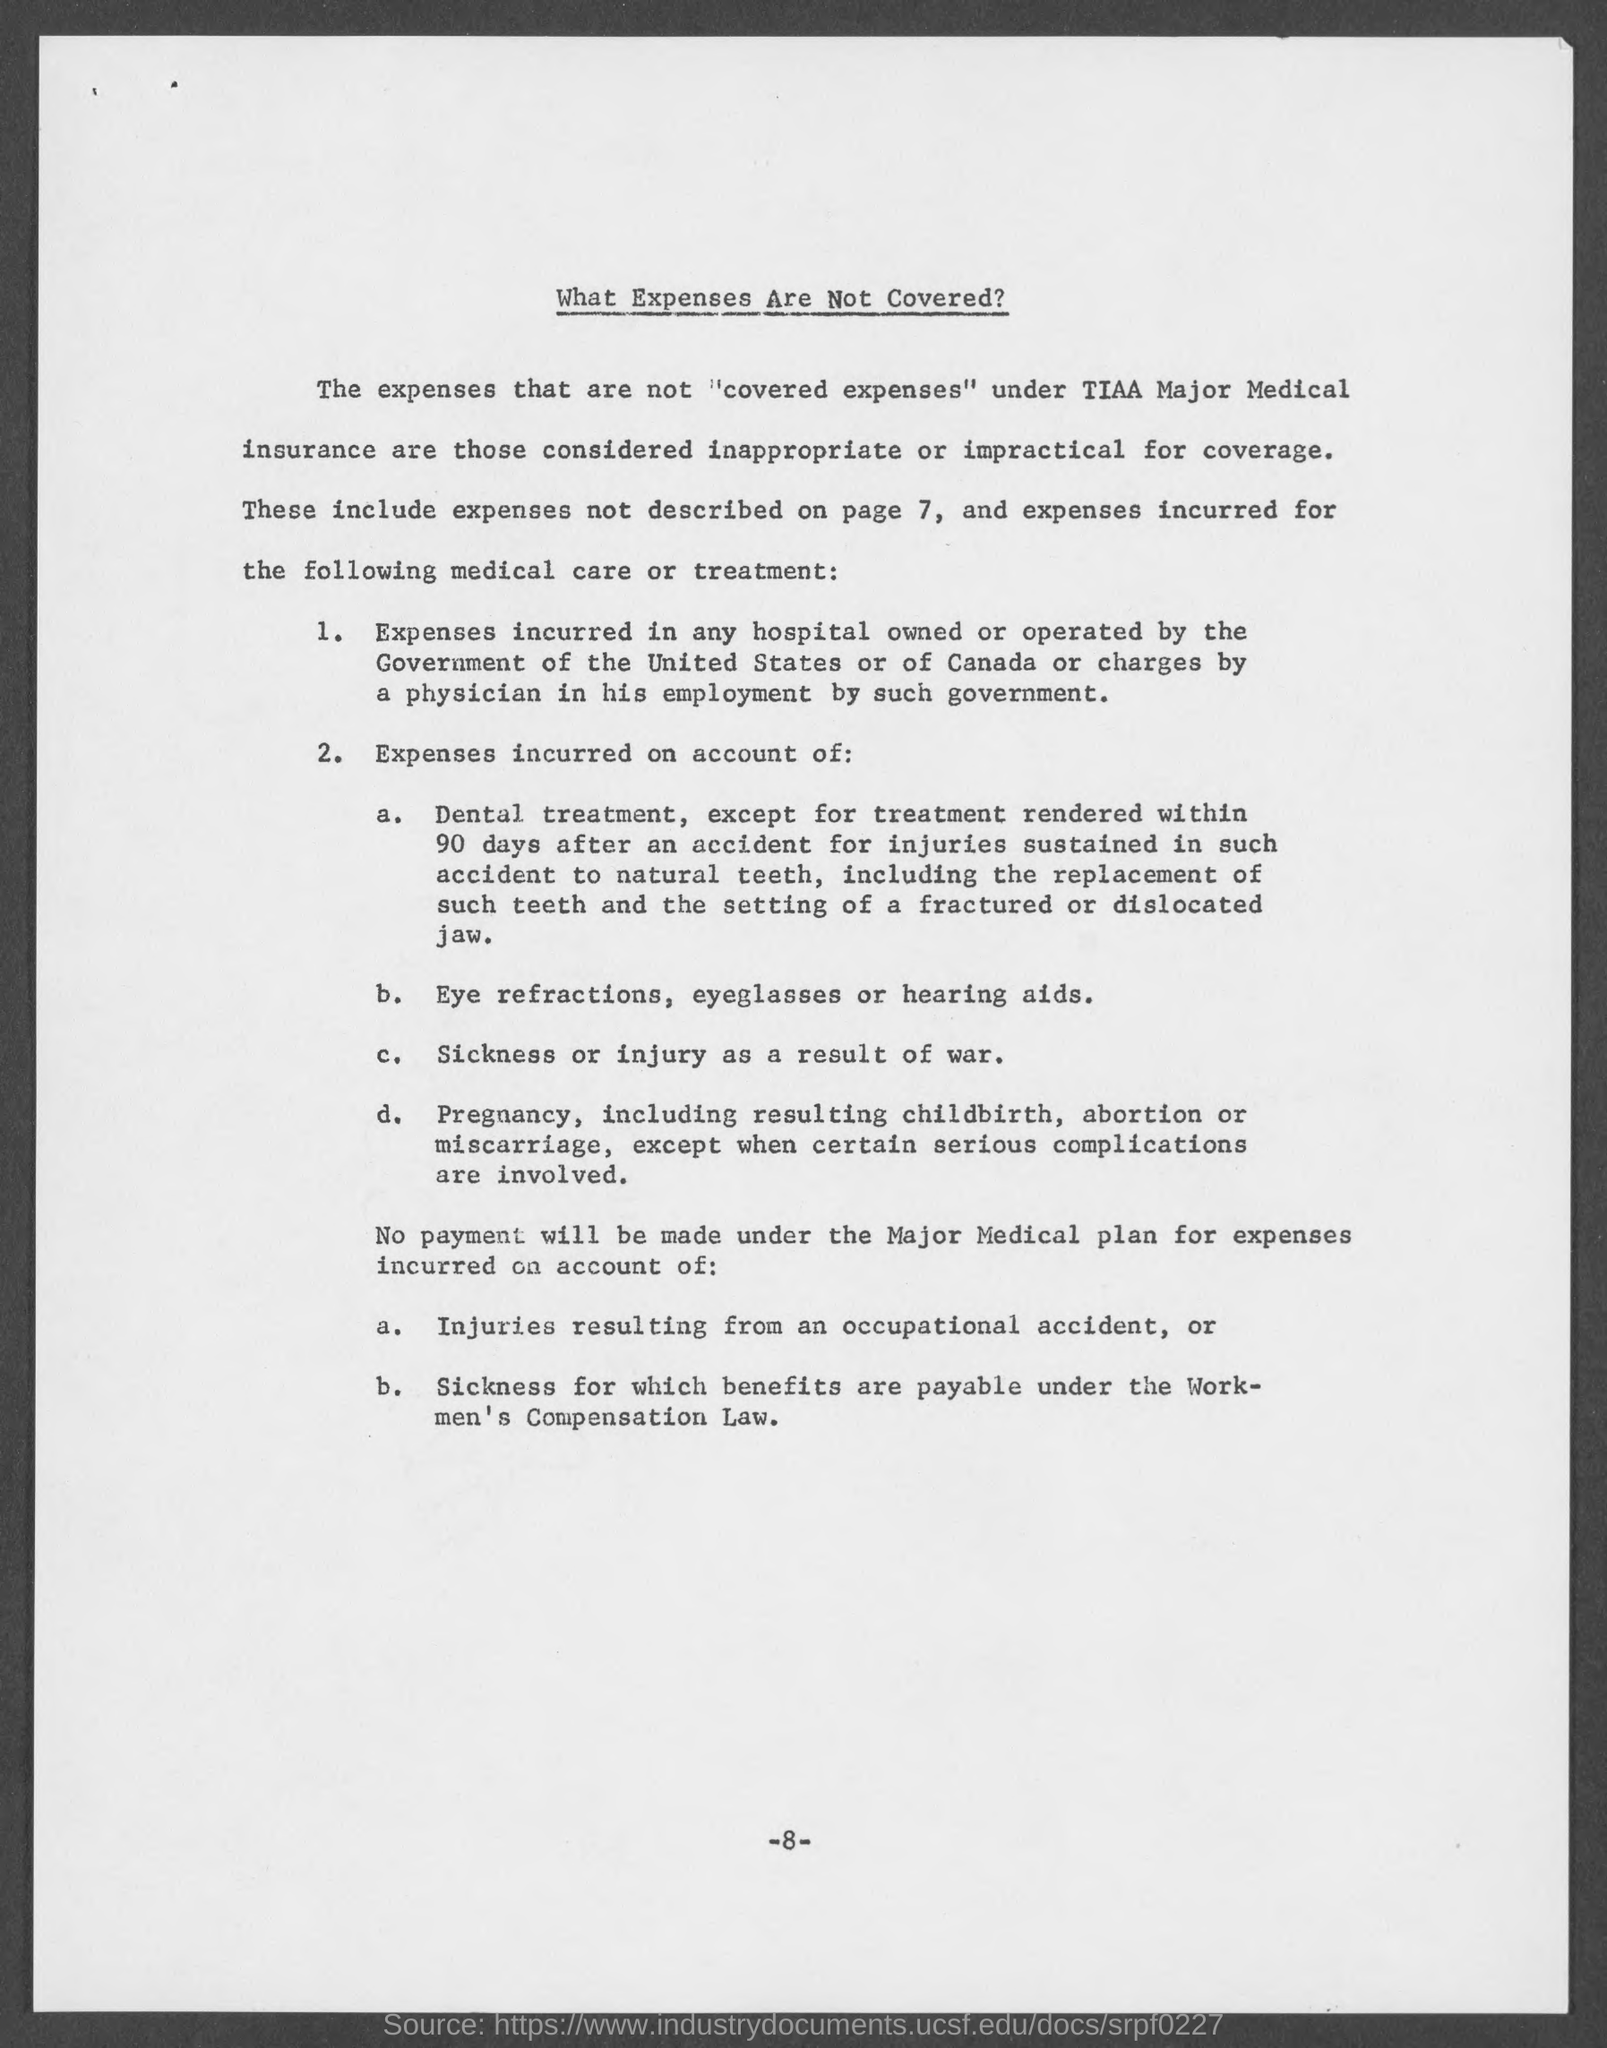What is the document title?
Provide a short and direct response. What Expenses Are Not Covered?. 